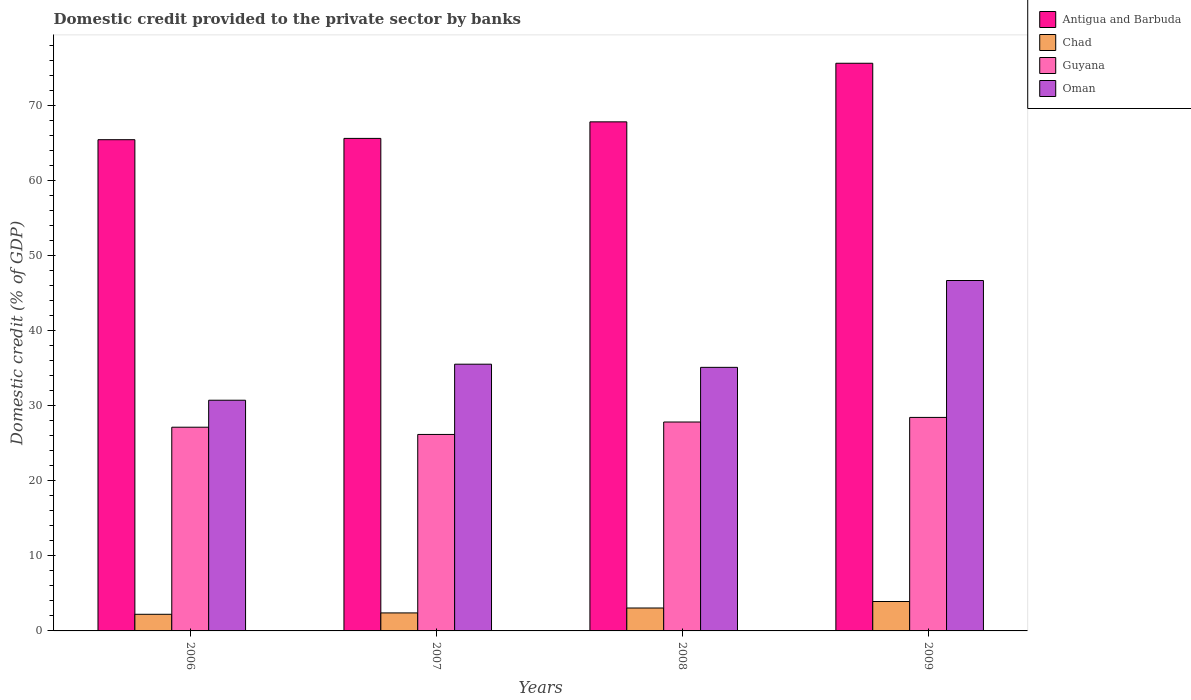How many groups of bars are there?
Offer a terse response. 4. How many bars are there on the 1st tick from the left?
Provide a succinct answer. 4. In how many cases, is the number of bars for a given year not equal to the number of legend labels?
Your answer should be compact. 0. What is the domestic credit provided to the private sector by banks in Oman in 2008?
Your response must be concise. 35.11. Across all years, what is the maximum domestic credit provided to the private sector by banks in Chad?
Your answer should be compact. 3.92. Across all years, what is the minimum domestic credit provided to the private sector by banks in Oman?
Make the answer very short. 30.73. In which year was the domestic credit provided to the private sector by banks in Antigua and Barbuda minimum?
Give a very brief answer. 2006. What is the total domestic credit provided to the private sector by banks in Guyana in the graph?
Provide a short and direct response. 109.57. What is the difference between the domestic credit provided to the private sector by banks in Guyana in 2006 and that in 2007?
Offer a terse response. 0.96. What is the difference between the domestic credit provided to the private sector by banks in Antigua and Barbuda in 2007 and the domestic credit provided to the private sector by banks in Guyana in 2009?
Offer a terse response. 37.17. What is the average domestic credit provided to the private sector by banks in Guyana per year?
Offer a very short reply. 27.39. In the year 2009, what is the difference between the domestic credit provided to the private sector by banks in Antigua and Barbuda and domestic credit provided to the private sector by banks in Oman?
Keep it short and to the point. 28.94. What is the ratio of the domestic credit provided to the private sector by banks in Oman in 2007 to that in 2009?
Provide a succinct answer. 0.76. What is the difference between the highest and the second highest domestic credit provided to the private sector by banks in Antigua and Barbuda?
Ensure brevity in your answer.  7.8. What is the difference between the highest and the lowest domestic credit provided to the private sector by banks in Chad?
Offer a very short reply. 1.7. In how many years, is the domestic credit provided to the private sector by banks in Oman greater than the average domestic credit provided to the private sector by banks in Oman taken over all years?
Provide a succinct answer. 1. Is it the case that in every year, the sum of the domestic credit provided to the private sector by banks in Antigua and Barbuda and domestic credit provided to the private sector by banks in Oman is greater than the sum of domestic credit provided to the private sector by banks in Chad and domestic credit provided to the private sector by banks in Guyana?
Your response must be concise. Yes. What does the 3rd bar from the left in 2007 represents?
Offer a very short reply. Guyana. What does the 2nd bar from the right in 2009 represents?
Your answer should be compact. Guyana. How many bars are there?
Offer a very short reply. 16. Are the values on the major ticks of Y-axis written in scientific E-notation?
Make the answer very short. No. Does the graph contain grids?
Keep it short and to the point. No. Where does the legend appear in the graph?
Provide a short and direct response. Top right. How many legend labels are there?
Provide a short and direct response. 4. What is the title of the graph?
Provide a succinct answer. Domestic credit provided to the private sector by banks. What is the label or title of the X-axis?
Keep it short and to the point. Years. What is the label or title of the Y-axis?
Your answer should be compact. Domestic credit (% of GDP). What is the Domestic credit (% of GDP) of Antigua and Barbuda in 2006?
Ensure brevity in your answer.  65.43. What is the Domestic credit (% of GDP) of Chad in 2006?
Give a very brief answer. 2.22. What is the Domestic credit (% of GDP) in Guyana in 2006?
Offer a terse response. 27.14. What is the Domestic credit (% of GDP) of Oman in 2006?
Keep it short and to the point. 30.73. What is the Domestic credit (% of GDP) in Antigua and Barbuda in 2007?
Offer a terse response. 65.61. What is the Domestic credit (% of GDP) in Chad in 2007?
Provide a short and direct response. 2.4. What is the Domestic credit (% of GDP) in Guyana in 2007?
Provide a succinct answer. 26.17. What is the Domestic credit (% of GDP) of Oman in 2007?
Ensure brevity in your answer.  35.53. What is the Domestic credit (% of GDP) of Antigua and Barbuda in 2008?
Your response must be concise. 67.81. What is the Domestic credit (% of GDP) in Chad in 2008?
Offer a terse response. 3.05. What is the Domestic credit (% of GDP) of Guyana in 2008?
Provide a short and direct response. 27.83. What is the Domestic credit (% of GDP) in Oman in 2008?
Your answer should be compact. 35.11. What is the Domestic credit (% of GDP) of Antigua and Barbuda in 2009?
Offer a terse response. 75.61. What is the Domestic credit (% of GDP) in Chad in 2009?
Offer a terse response. 3.92. What is the Domestic credit (% of GDP) in Guyana in 2009?
Give a very brief answer. 28.44. What is the Domestic credit (% of GDP) in Oman in 2009?
Make the answer very short. 46.68. Across all years, what is the maximum Domestic credit (% of GDP) of Antigua and Barbuda?
Your answer should be very brief. 75.61. Across all years, what is the maximum Domestic credit (% of GDP) in Chad?
Offer a terse response. 3.92. Across all years, what is the maximum Domestic credit (% of GDP) in Guyana?
Make the answer very short. 28.44. Across all years, what is the maximum Domestic credit (% of GDP) of Oman?
Offer a terse response. 46.68. Across all years, what is the minimum Domestic credit (% of GDP) of Antigua and Barbuda?
Give a very brief answer. 65.43. Across all years, what is the minimum Domestic credit (% of GDP) in Chad?
Your answer should be very brief. 2.22. Across all years, what is the minimum Domestic credit (% of GDP) of Guyana?
Your response must be concise. 26.17. Across all years, what is the minimum Domestic credit (% of GDP) in Oman?
Your response must be concise. 30.73. What is the total Domestic credit (% of GDP) in Antigua and Barbuda in the graph?
Your answer should be very brief. 274.46. What is the total Domestic credit (% of GDP) of Chad in the graph?
Provide a succinct answer. 11.58. What is the total Domestic credit (% of GDP) in Guyana in the graph?
Ensure brevity in your answer.  109.57. What is the total Domestic credit (% of GDP) of Oman in the graph?
Give a very brief answer. 148.04. What is the difference between the Domestic credit (% of GDP) of Antigua and Barbuda in 2006 and that in 2007?
Make the answer very short. -0.17. What is the difference between the Domestic credit (% of GDP) in Chad in 2006 and that in 2007?
Offer a very short reply. -0.18. What is the difference between the Domestic credit (% of GDP) of Guyana in 2006 and that in 2007?
Your answer should be compact. 0.96. What is the difference between the Domestic credit (% of GDP) in Oman in 2006 and that in 2007?
Your answer should be very brief. -4.8. What is the difference between the Domestic credit (% of GDP) of Antigua and Barbuda in 2006 and that in 2008?
Keep it short and to the point. -2.38. What is the difference between the Domestic credit (% of GDP) in Chad in 2006 and that in 2008?
Your answer should be very brief. -0.84. What is the difference between the Domestic credit (% of GDP) of Guyana in 2006 and that in 2008?
Offer a very short reply. -0.69. What is the difference between the Domestic credit (% of GDP) in Oman in 2006 and that in 2008?
Keep it short and to the point. -4.38. What is the difference between the Domestic credit (% of GDP) of Antigua and Barbuda in 2006 and that in 2009?
Offer a very short reply. -10.18. What is the difference between the Domestic credit (% of GDP) of Chad in 2006 and that in 2009?
Your response must be concise. -1.7. What is the difference between the Domestic credit (% of GDP) of Guyana in 2006 and that in 2009?
Offer a very short reply. -1.3. What is the difference between the Domestic credit (% of GDP) of Oman in 2006 and that in 2009?
Your response must be concise. -15.95. What is the difference between the Domestic credit (% of GDP) of Antigua and Barbuda in 2007 and that in 2008?
Offer a very short reply. -2.2. What is the difference between the Domestic credit (% of GDP) in Chad in 2007 and that in 2008?
Offer a terse response. -0.65. What is the difference between the Domestic credit (% of GDP) of Guyana in 2007 and that in 2008?
Make the answer very short. -1.66. What is the difference between the Domestic credit (% of GDP) of Oman in 2007 and that in 2008?
Provide a succinct answer. 0.42. What is the difference between the Domestic credit (% of GDP) in Antigua and Barbuda in 2007 and that in 2009?
Make the answer very short. -10.01. What is the difference between the Domestic credit (% of GDP) of Chad in 2007 and that in 2009?
Offer a terse response. -1.52. What is the difference between the Domestic credit (% of GDP) in Guyana in 2007 and that in 2009?
Keep it short and to the point. -2.27. What is the difference between the Domestic credit (% of GDP) of Oman in 2007 and that in 2009?
Your answer should be very brief. -11.15. What is the difference between the Domestic credit (% of GDP) in Antigua and Barbuda in 2008 and that in 2009?
Ensure brevity in your answer.  -7.8. What is the difference between the Domestic credit (% of GDP) in Chad in 2008 and that in 2009?
Give a very brief answer. -0.87. What is the difference between the Domestic credit (% of GDP) in Guyana in 2008 and that in 2009?
Give a very brief answer. -0.61. What is the difference between the Domestic credit (% of GDP) of Oman in 2008 and that in 2009?
Your answer should be very brief. -11.57. What is the difference between the Domestic credit (% of GDP) of Antigua and Barbuda in 2006 and the Domestic credit (% of GDP) of Chad in 2007?
Make the answer very short. 63.04. What is the difference between the Domestic credit (% of GDP) of Antigua and Barbuda in 2006 and the Domestic credit (% of GDP) of Guyana in 2007?
Keep it short and to the point. 39.26. What is the difference between the Domestic credit (% of GDP) in Antigua and Barbuda in 2006 and the Domestic credit (% of GDP) in Oman in 2007?
Your response must be concise. 29.91. What is the difference between the Domestic credit (% of GDP) of Chad in 2006 and the Domestic credit (% of GDP) of Guyana in 2007?
Ensure brevity in your answer.  -23.96. What is the difference between the Domestic credit (% of GDP) of Chad in 2006 and the Domestic credit (% of GDP) of Oman in 2007?
Provide a short and direct response. -33.31. What is the difference between the Domestic credit (% of GDP) in Guyana in 2006 and the Domestic credit (% of GDP) in Oman in 2007?
Keep it short and to the point. -8.39. What is the difference between the Domestic credit (% of GDP) in Antigua and Barbuda in 2006 and the Domestic credit (% of GDP) in Chad in 2008?
Provide a succinct answer. 62.38. What is the difference between the Domestic credit (% of GDP) in Antigua and Barbuda in 2006 and the Domestic credit (% of GDP) in Guyana in 2008?
Your response must be concise. 37.6. What is the difference between the Domestic credit (% of GDP) in Antigua and Barbuda in 2006 and the Domestic credit (% of GDP) in Oman in 2008?
Ensure brevity in your answer.  30.33. What is the difference between the Domestic credit (% of GDP) of Chad in 2006 and the Domestic credit (% of GDP) of Guyana in 2008?
Keep it short and to the point. -25.61. What is the difference between the Domestic credit (% of GDP) of Chad in 2006 and the Domestic credit (% of GDP) of Oman in 2008?
Provide a succinct answer. -32.89. What is the difference between the Domestic credit (% of GDP) of Guyana in 2006 and the Domestic credit (% of GDP) of Oman in 2008?
Ensure brevity in your answer.  -7.97. What is the difference between the Domestic credit (% of GDP) in Antigua and Barbuda in 2006 and the Domestic credit (% of GDP) in Chad in 2009?
Give a very brief answer. 61.51. What is the difference between the Domestic credit (% of GDP) in Antigua and Barbuda in 2006 and the Domestic credit (% of GDP) in Guyana in 2009?
Your response must be concise. 36.99. What is the difference between the Domestic credit (% of GDP) of Antigua and Barbuda in 2006 and the Domestic credit (% of GDP) of Oman in 2009?
Ensure brevity in your answer.  18.76. What is the difference between the Domestic credit (% of GDP) of Chad in 2006 and the Domestic credit (% of GDP) of Guyana in 2009?
Your answer should be compact. -26.22. What is the difference between the Domestic credit (% of GDP) of Chad in 2006 and the Domestic credit (% of GDP) of Oman in 2009?
Your answer should be compact. -44.46. What is the difference between the Domestic credit (% of GDP) in Guyana in 2006 and the Domestic credit (% of GDP) in Oman in 2009?
Your response must be concise. -19.54. What is the difference between the Domestic credit (% of GDP) of Antigua and Barbuda in 2007 and the Domestic credit (% of GDP) of Chad in 2008?
Offer a very short reply. 62.55. What is the difference between the Domestic credit (% of GDP) of Antigua and Barbuda in 2007 and the Domestic credit (% of GDP) of Guyana in 2008?
Offer a terse response. 37.78. What is the difference between the Domestic credit (% of GDP) of Antigua and Barbuda in 2007 and the Domestic credit (% of GDP) of Oman in 2008?
Make the answer very short. 30.5. What is the difference between the Domestic credit (% of GDP) in Chad in 2007 and the Domestic credit (% of GDP) in Guyana in 2008?
Offer a very short reply. -25.43. What is the difference between the Domestic credit (% of GDP) in Chad in 2007 and the Domestic credit (% of GDP) in Oman in 2008?
Keep it short and to the point. -32.71. What is the difference between the Domestic credit (% of GDP) of Guyana in 2007 and the Domestic credit (% of GDP) of Oman in 2008?
Your response must be concise. -8.94. What is the difference between the Domestic credit (% of GDP) of Antigua and Barbuda in 2007 and the Domestic credit (% of GDP) of Chad in 2009?
Your response must be concise. 61.69. What is the difference between the Domestic credit (% of GDP) of Antigua and Barbuda in 2007 and the Domestic credit (% of GDP) of Guyana in 2009?
Give a very brief answer. 37.17. What is the difference between the Domestic credit (% of GDP) of Antigua and Barbuda in 2007 and the Domestic credit (% of GDP) of Oman in 2009?
Provide a short and direct response. 18.93. What is the difference between the Domestic credit (% of GDP) of Chad in 2007 and the Domestic credit (% of GDP) of Guyana in 2009?
Give a very brief answer. -26.04. What is the difference between the Domestic credit (% of GDP) of Chad in 2007 and the Domestic credit (% of GDP) of Oman in 2009?
Ensure brevity in your answer.  -44.28. What is the difference between the Domestic credit (% of GDP) in Guyana in 2007 and the Domestic credit (% of GDP) in Oman in 2009?
Offer a terse response. -20.5. What is the difference between the Domestic credit (% of GDP) of Antigua and Barbuda in 2008 and the Domestic credit (% of GDP) of Chad in 2009?
Your response must be concise. 63.89. What is the difference between the Domestic credit (% of GDP) of Antigua and Barbuda in 2008 and the Domestic credit (% of GDP) of Guyana in 2009?
Your response must be concise. 39.37. What is the difference between the Domestic credit (% of GDP) of Antigua and Barbuda in 2008 and the Domestic credit (% of GDP) of Oman in 2009?
Your answer should be very brief. 21.13. What is the difference between the Domestic credit (% of GDP) in Chad in 2008 and the Domestic credit (% of GDP) in Guyana in 2009?
Give a very brief answer. -25.39. What is the difference between the Domestic credit (% of GDP) in Chad in 2008 and the Domestic credit (% of GDP) in Oman in 2009?
Ensure brevity in your answer.  -43.63. What is the difference between the Domestic credit (% of GDP) of Guyana in 2008 and the Domestic credit (% of GDP) of Oman in 2009?
Give a very brief answer. -18.85. What is the average Domestic credit (% of GDP) in Antigua and Barbuda per year?
Make the answer very short. 68.62. What is the average Domestic credit (% of GDP) of Chad per year?
Keep it short and to the point. 2.9. What is the average Domestic credit (% of GDP) of Guyana per year?
Offer a terse response. 27.39. What is the average Domestic credit (% of GDP) of Oman per year?
Give a very brief answer. 37.01. In the year 2006, what is the difference between the Domestic credit (% of GDP) of Antigua and Barbuda and Domestic credit (% of GDP) of Chad?
Your answer should be compact. 63.22. In the year 2006, what is the difference between the Domestic credit (% of GDP) in Antigua and Barbuda and Domestic credit (% of GDP) in Guyana?
Ensure brevity in your answer.  38.3. In the year 2006, what is the difference between the Domestic credit (% of GDP) in Antigua and Barbuda and Domestic credit (% of GDP) in Oman?
Ensure brevity in your answer.  34.7. In the year 2006, what is the difference between the Domestic credit (% of GDP) of Chad and Domestic credit (% of GDP) of Guyana?
Your answer should be very brief. -24.92. In the year 2006, what is the difference between the Domestic credit (% of GDP) of Chad and Domestic credit (% of GDP) of Oman?
Your answer should be compact. -28.51. In the year 2006, what is the difference between the Domestic credit (% of GDP) of Guyana and Domestic credit (% of GDP) of Oman?
Make the answer very short. -3.59. In the year 2007, what is the difference between the Domestic credit (% of GDP) of Antigua and Barbuda and Domestic credit (% of GDP) of Chad?
Make the answer very short. 63.21. In the year 2007, what is the difference between the Domestic credit (% of GDP) of Antigua and Barbuda and Domestic credit (% of GDP) of Guyana?
Offer a very short reply. 39.43. In the year 2007, what is the difference between the Domestic credit (% of GDP) in Antigua and Barbuda and Domestic credit (% of GDP) in Oman?
Ensure brevity in your answer.  30.08. In the year 2007, what is the difference between the Domestic credit (% of GDP) in Chad and Domestic credit (% of GDP) in Guyana?
Give a very brief answer. -23.77. In the year 2007, what is the difference between the Domestic credit (% of GDP) of Chad and Domestic credit (% of GDP) of Oman?
Your response must be concise. -33.13. In the year 2007, what is the difference between the Domestic credit (% of GDP) of Guyana and Domestic credit (% of GDP) of Oman?
Your answer should be very brief. -9.36. In the year 2008, what is the difference between the Domestic credit (% of GDP) of Antigua and Barbuda and Domestic credit (% of GDP) of Chad?
Provide a short and direct response. 64.76. In the year 2008, what is the difference between the Domestic credit (% of GDP) in Antigua and Barbuda and Domestic credit (% of GDP) in Guyana?
Make the answer very short. 39.98. In the year 2008, what is the difference between the Domestic credit (% of GDP) in Antigua and Barbuda and Domestic credit (% of GDP) in Oman?
Ensure brevity in your answer.  32.7. In the year 2008, what is the difference between the Domestic credit (% of GDP) in Chad and Domestic credit (% of GDP) in Guyana?
Your answer should be compact. -24.78. In the year 2008, what is the difference between the Domestic credit (% of GDP) of Chad and Domestic credit (% of GDP) of Oman?
Provide a short and direct response. -32.06. In the year 2008, what is the difference between the Domestic credit (% of GDP) of Guyana and Domestic credit (% of GDP) of Oman?
Offer a very short reply. -7.28. In the year 2009, what is the difference between the Domestic credit (% of GDP) of Antigua and Barbuda and Domestic credit (% of GDP) of Chad?
Provide a short and direct response. 71.7. In the year 2009, what is the difference between the Domestic credit (% of GDP) of Antigua and Barbuda and Domestic credit (% of GDP) of Guyana?
Your response must be concise. 47.17. In the year 2009, what is the difference between the Domestic credit (% of GDP) in Antigua and Barbuda and Domestic credit (% of GDP) in Oman?
Offer a terse response. 28.94. In the year 2009, what is the difference between the Domestic credit (% of GDP) of Chad and Domestic credit (% of GDP) of Guyana?
Make the answer very short. -24.52. In the year 2009, what is the difference between the Domestic credit (% of GDP) of Chad and Domestic credit (% of GDP) of Oman?
Keep it short and to the point. -42.76. In the year 2009, what is the difference between the Domestic credit (% of GDP) in Guyana and Domestic credit (% of GDP) in Oman?
Ensure brevity in your answer.  -18.24. What is the ratio of the Domestic credit (% of GDP) of Antigua and Barbuda in 2006 to that in 2007?
Ensure brevity in your answer.  1. What is the ratio of the Domestic credit (% of GDP) in Chad in 2006 to that in 2007?
Provide a short and direct response. 0.92. What is the ratio of the Domestic credit (% of GDP) in Guyana in 2006 to that in 2007?
Give a very brief answer. 1.04. What is the ratio of the Domestic credit (% of GDP) in Oman in 2006 to that in 2007?
Ensure brevity in your answer.  0.86. What is the ratio of the Domestic credit (% of GDP) of Antigua and Barbuda in 2006 to that in 2008?
Your answer should be very brief. 0.96. What is the ratio of the Domestic credit (% of GDP) of Chad in 2006 to that in 2008?
Your response must be concise. 0.73. What is the ratio of the Domestic credit (% of GDP) of Guyana in 2006 to that in 2008?
Your response must be concise. 0.98. What is the ratio of the Domestic credit (% of GDP) of Oman in 2006 to that in 2008?
Make the answer very short. 0.88. What is the ratio of the Domestic credit (% of GDP) of Antigua and Barbuda in 2006 to that in 2009?
Provide a succinct answer. 0.87. What is the ratio of the Domestic credit (% of GDP) in Chad in 2006 to that in 2009?
Make the answer very short. 0.57. What is the ratio of the Domestic credit (% of GDP) of Guyana in 2006 to that in 2009?
Offer a terse response. 0.95. What is the ratio of the Domestic credit (% of GDP) of Oman in 2006 to that in 2009?
Offer a very short reply. 0.66. What is the ratio of the Domestic credit (% of GDP) in Antigua and Barbuda in 2007 to that in 2008?
Offer a terse response. 0.97. What is the ratio of the Domestic credit (% of GDP) of Chad in 2007 to that in 2008?
Provide a short and direct response. 0.79. What is the ratio of the Domestic credit (% of GDP) of Guyana in 2007 to that in 2008?
Keep it short and to the point. 0.94. What is the ratio of the Domestic credit (% of GDP) in Oman in 2007 to that in 2008?
Offer a very short reply. 1.01. What is the ratio of the Domestic credit (% of GDP) of Antigua and Barbuda in 2007 to that in 2009?
Keep it short and to the point. 0.87. What is the ratio of the Domestic credit (% of GDP) in Chad in 2007 to that in 2009?
Your answer should be very brief. 0.61. What is the ratio of the Domestic credit (% of GDP) of Guyana in 2007 to that in 2009?
Provide a short and direct response. 0.92. What is the ratio of the Domestic credit (% of GDP) in Oman in 2007 to that in 2009?
Your answer should be compact. 0.76. What is the ratio of the Domestic credit (% of GDP) of Antigua and Barbuda in 2008 to that in 2009?
Your response must be concise. 0.9. What is the ratio of the Domestic credit (% of GDP) in Chad in 2008 to that in 2009?
Provide a short and direct response. 0.78. What is the ratio of the Domestic credit (% of GDP) of Guyana in 2008 to that in 2009?
Provide a succinct answer. 0.98. What is the ratio of the Domestic credit (% of GDP) of Oman in 2008 to that in 2009?
Your response must be concise. 0.75. What is the difference between the highest and the second highest Domestic credit (% of GDP) of Antigua and Barbuda?
Keep it short and to the point. 7.8. What is the difference between the highest and the second highest Domestic credit (% of GDP) in Chad?
Your answer should be very brief. 0.87. What is the difference between the highest and the second highest Domestic credit (% of GDP) in Guyana?
Offer a terse response. 0.61. What is the difference between the highest and the second highest Domestic credit (% of GDP) in Oman?
Provide a succinct answer. 11.15. What is the difference between the highest and the lowest Domestic credit (% of GDP) of Antigua and Barbuda?
Make the answer very short. 10.18. What is the difference between the highest and the lowest Domestic credit (% of GDP) of Chad?
Your answer should be compact. 1.7. What is the difference between the highest and the lowest Domestic credit (% of GDP) of Guyana?
Your answer should be very brief. 2.27. What is the difference between the highest and the lowest Domestic credit (% of GDP) of Oman?
Give a very brief answer. 15.95. 